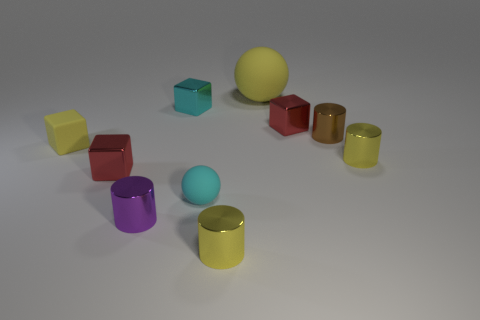How many red cubes must be subtracted to get 1 red cubes? 1 Subtract 1 cubes. How many cubes are left? 3 Subtract all cylinders. How many objects are left? 6 Subtract 0 red cylinders. How many objects are left? 10 Subtract all blue metallic things. Subtract all red metallic cubes. How many objects are left? 8 Add 5 rubber blocks. How many rubber blocks are left? 6 Add 3 shiny cylinders. How many shiny cylinders exist? 7 